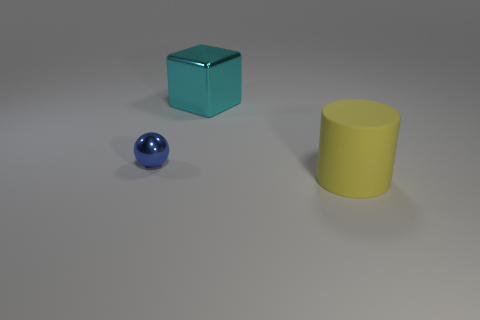Add 3 brown balls. How many objects exist? 6 Subtract all balls. How many objects are left? 2 Subtract all large matte cylinders. Subtract all yellow rubber things. How many objects are left? 1 Add 3 big rubber things. How many big rubber things are left? 4 Add 1 small blue things. How many small blue things exist? 2 Subtract 0 purple blocks. How many objects are left? 3 